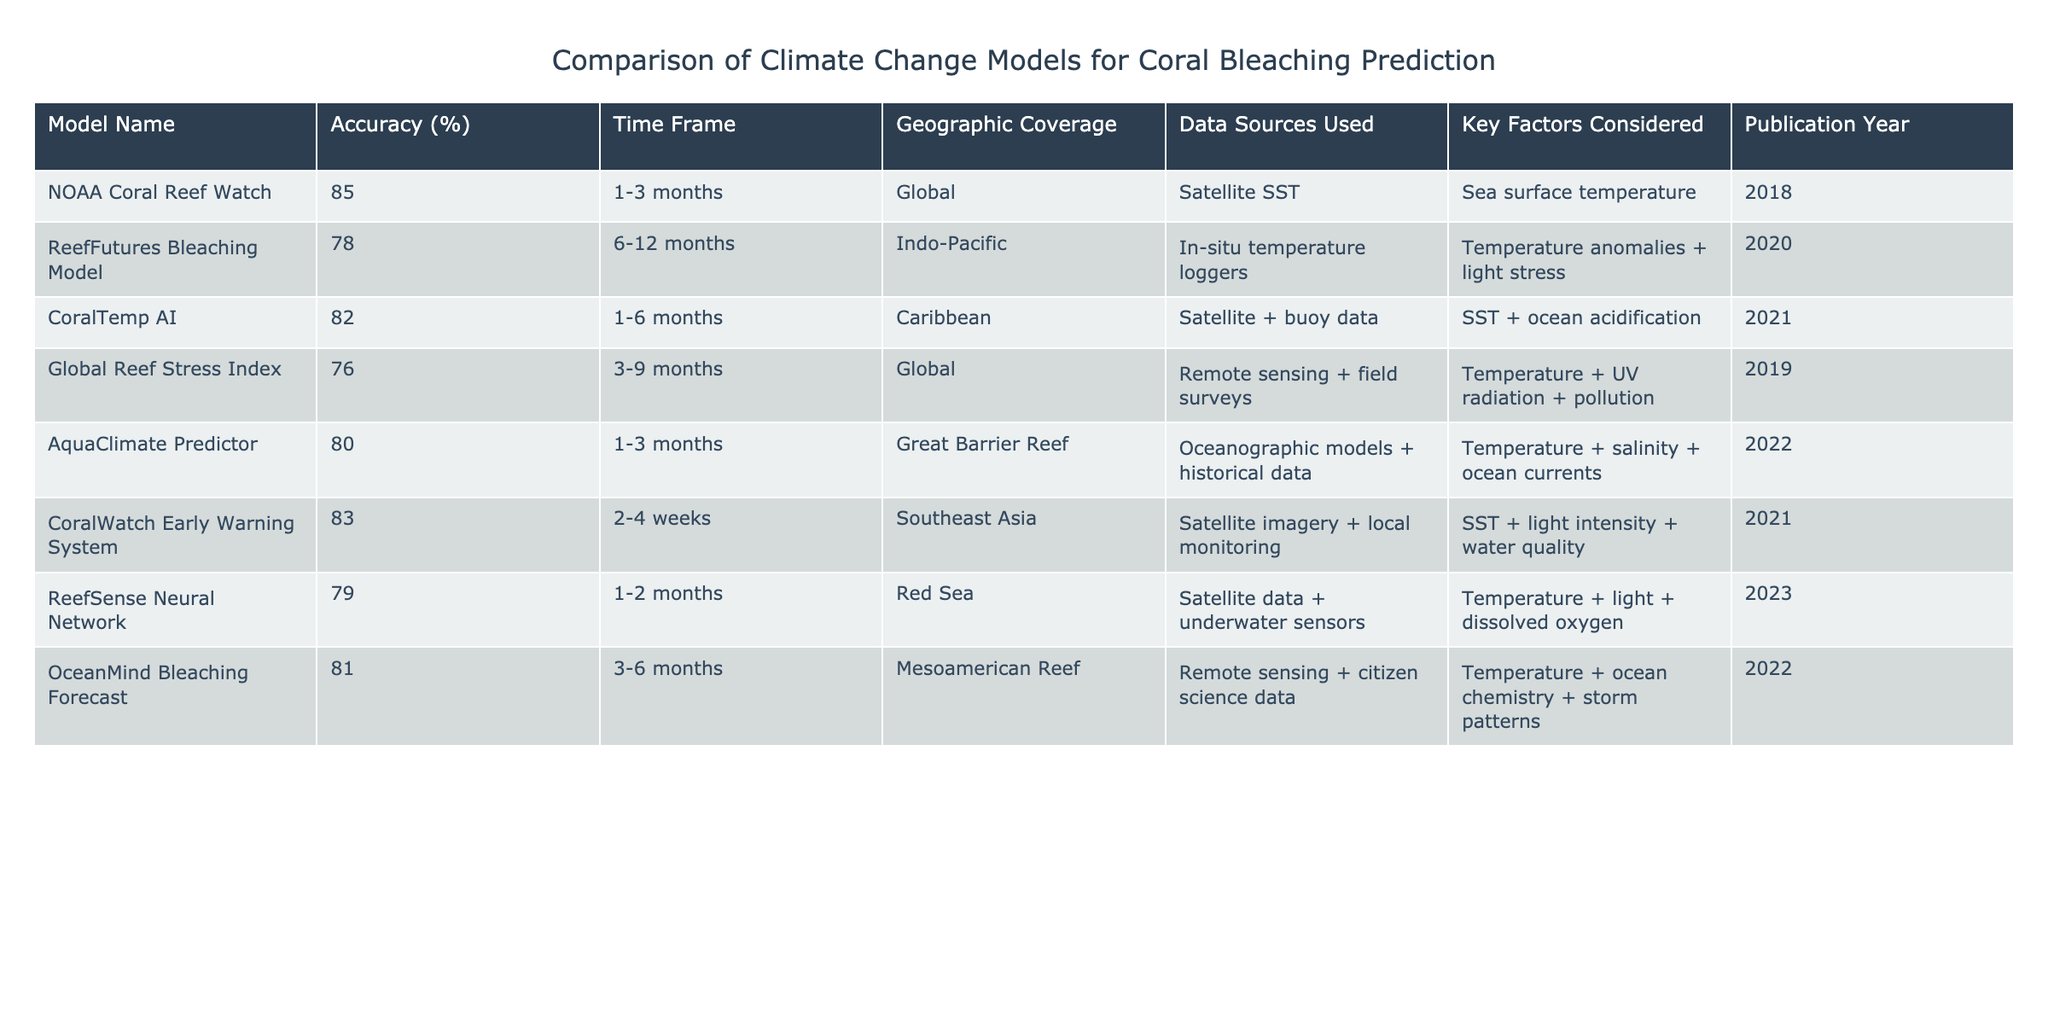What is the accuracy of the NOAA Coral Reef Watch model? The table shows that the accuracy of the NOAA Coral Reef Watch model is listed as 85%.
Answer: 85% Which model has the lowest accuracy in predicting coral bleaching events? By examining the accuracy values in the table, the Global Reef Stress Index has the lowest accuracy at 76%.
Answer: Global Reef Stress Index How many models consider the factors of temperature and light? Looking at the table, the ReefSense Neural Network, ReefFutures Bleaching Model, and CoralWatch Early Warning System all consider temperature and light as factors, totaling three models.
Answer: 3 What is the average accuracy of the models that use satellite data? The models that use satellite data and their accuracies are NOAA Coral Reef Watch (85%), CoralTemp AI (82%), and ReefSense Neural Network (79%). The total accuracy is 85 + 82 + 79 = 246, and there are three models, so the average is 246 / 3 = 82.
Answer: 82 Does the AquaClimate Predictor have a publication year after 2020? By checking the publication year in the table, AquaClimate Predictor was published in 2022, which is after 2020.
Answer: Yes Which model covers the largest geographic area? The NOAA Coral Reef Watch model has 'Global' geographic coverage, which suggests it covers the largest area compared to other models with specified regions.
Answer: NOAA Coral Reef Watch What is the difference in accuracy between the CoralTemp AI and OceanMind Bleaching Forecast models? The accuracy for CoralTemp AI is 82% and for OceanMind Bleaching Forecast is 81%. The difference in their accuracies is 82 - 81 = 1%.
Answer: 1% How many models have a prediction time frame of less than three months? The table shows that the NOAA Coral Reef Watch and CoralWatch Early Warning System both have prediction time frames of less than three months, totaling two models.
Answer: 2 Which model considers ocean acidification as a factor? Looking at the table, the CoralTemp AI model includes ocean acidification as one of the key factors considered.
Answer: CoralTemp AI 